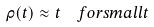Convert formula to latex. <formula><loc_0><loc_0><loc_500><loc_500>\rho ( t ) \approx t \ \ f o r s m a l l t</formula> 